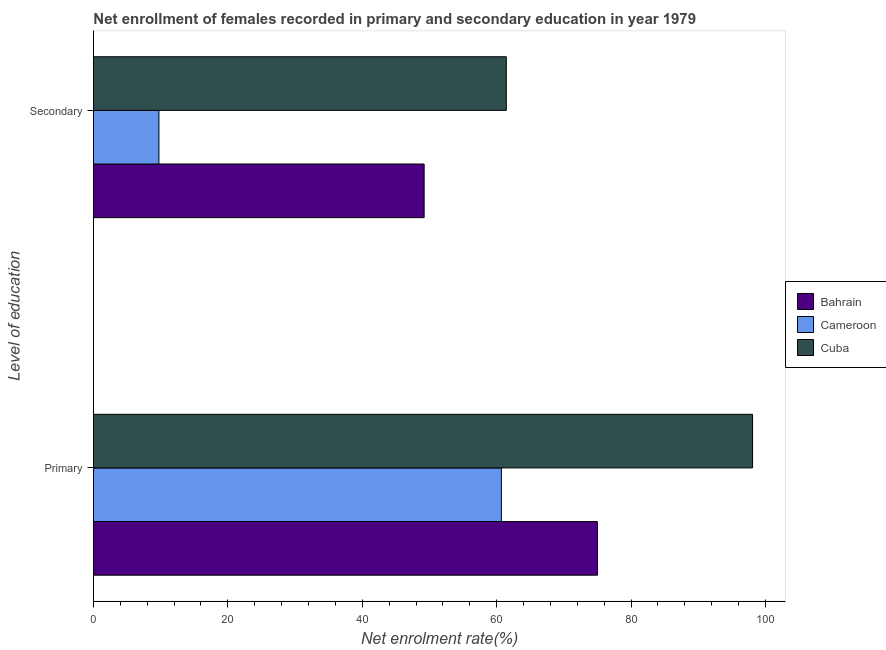How many different coloured bars are there?
Give a very brief answer. 3. How many groups of bars are there?
Offer a very short reply. 2. Are the number of bars on each tick of the Y-axis equal?
Offer a very short reply. Yes. What is the label of the 1st group of bars from the top?
Offer a very short reply. Secondary. What is the enrollment rate in secondary education in Cuba?
Offer a terse response. 61.44. Across all countries, what is the maximum enrollment rate in secondary education?
Your answer should be compact. 61.44. Across all countries, what is the minimum enrollment rate in secondary education?
Make the answer very short. 9.74. In which country was the enrollment rate in primary education maximum?
Your answer should be compact. Cuba. In which country was the enrollment rate in primary education minimum?
Provide a succinct answer. Cameroon. What is the total enrollment rate in primary education in the graph?
Provide a short and direct response. 233.79. What is the difference between the enrollment rate in primary education in Cuba and that in Bahrain?
Give a very brief answer. 23.09. What is the difference between the enrollment rate in primary education in Bahrain and the enrollment rate in secondary education in Cuba?
Offer a very short reply. 13.56. What is the average enrollment rate in primary education per country?
Offer a very short reply. 77.93. What is the difference between the enrollment rate in primary education and enrollment rate in secondary education in Cameroon?
Your answer should be very brief. 50.97. What is the ratio of the enrollment rate in primary education in Bahrain to that in Cuba?
Your answer should be compact. 0.76. Is the enrollment rate in primary education in Bahrain less than that in Cuba?
Keep it short and to the point. Yes. What does the 3rd bar from the top in Secondary represents?
Keep it short and to the point. Bahrain. What does the 1st bar from the bottom in Secondary represents?
Provide a succinct answer. Bahrain. How many countries are there in the graph?
Your response must be concise. 3. What is the difference between two consecutive major ticks on the X-axis?
Give a very brief answer. 20. Are the values on the major ticks of X-axis written in scientific E-notation?
Give a very brief answer. No. Does the graph contain any zero values?
Give a very brief answer. No. How are the legend labels stacked?
Your answer should be very brief. Vertical. What is the title of the graph?
Offer a terse response. Net enrollment of females recorded in primary and secondary education in year 1979. What is the label or title of the X-axis?
Give a very brief answer. Net enrolment rate(%). What is the label or title of the Y-axis?
Keep it short and to the point. Level of education. What is the Net enrolment rate(%) of Bahrain in Primary?
Provide a succinct answer. 75. What is the Net enrolment rate(%) of Cameroon in Primary?
Provide a short and direct response. 60.71. What is the Net enrolment rate(%) in Cuba in Primary?
Ensure brevity in your answer.  98.08. What is the Net enrolment rate(%) of Bahrain in Secondary?
Offer a very short reply. 49.21. What is the Net enrolment rate(%) of Cameroon in Secondary?
Provide a short and direct response. 9.74. What is the Net enrolment rate(%) of Cuba in Secondary?
Provide a succinct answer. 61.44. Across all Level of education, what is the maximum Net enrolment rate(%) in Bahrain?
Provide a short and direct response. 75. Across all Level of education, what is the maximum Net enrolment rate(%) in Cameroon?
Provide a succinct answer. 60.71. Across all Level of education, what is the maximum Net enrolment rate(%) in Cuba?
Offer a very short reply. 98.08. Across all Level of education, what is the minimum Net enrolment rate(%) in Bahrain?
Your answer should be very brief. 49.21. Across all Level of education, what is the minimum Net enrolment rate(%) in Cameroon?
Ensure brevity in your answer.  9.74. Across all Level of education, what is the minimum Net enrolment rate(%) in Cuba?
Give a very brief answer. 61.44. What is the total Net enrolment rate(%) of Bahrain in the graph?
Ensure brevity in your answer.  124.21. What is the total Net enrolment rate(%) of Cameroon in the graph?
Offer a very short reply. 70.44. What is the total Net enrolment rate(%) in Cuba in the graph?
Offer a terse response. 159.52. What is the difference between the Net enrolment rate(%) in Bahrain in Primary and that in Secondary?
Provide a succinct answer. 25.79. What is the difference between the Net enrolment rate(%) in Cameroon in Primary and that in Secondary?
Keep it short and to the point. 50.97. What is the difference between the Net enrolment rate(%) in Cuba in Primary and that in Secondary?
Make the answer very short. 36.64. What is the difference between the Net enrolment rate(%) in Bahrain in Primary and the Net enrolment rate(%) in Cameroon in Secondary?
Your answer should be very brief. 65.26. What is the difference between the Net enrolment rate(%) in Bahrain in Primary and the Net enrolment rate(%) in Cuba in Secondary?
Your response must be concise. 13.56. What is the difference between the Net enrolment rate(%) in Cameroon in Primary and the Net enrolment rate(%) in Cuba in Secondary?
Ensure brevity in your answer.  -0.73. What is the average Net enrolment rate(%) of Bahrain per Level of education?
Keep it short and to the point. 62.1. What is the average Net enrolment rate(%) in Cameroon per Level of education?
Make the answer very short. 35.22. What is the average Net enrolment rate(%) of Cuba per Level of education?
Your answer should be very brief. 79.76. What is the difference between the Net enrolment rate(%) in Bahrain and Net enrolment rate(%) in Cameroon in Primary?
Your answer should be compact. 14.29. What is the difference between the Net enrolment rate(%) of Bahrain and Net enrolment rate(%) of Cuba in Primary?
Offer a very short reply. -23.09. What is the difference between the Net enrolment rate(%) of Cameroon and Net enrolment rate(%) of Cuba in Primary?
Offer a very short reply. -37.38. What is the difference between the Net enrolment rate(%) in Bahrain and Net enrolment rate(%) in Cameroon in Secondary?
Keep it short and to the point. 39.47. What is the difference between the Net enrolment rate(%) of Bahrain and Net enrolment rate(%) of Cuba in Secondary?
Make the answer very short. -12.23. What is the difference between the Net enrolment rate(%) in Cameroon and Net enrolment rate(%) in Cuba in Secondary?
Your answer should be compact. -51.7. What is the ratio of the Net enrolment rate(%) in Bahrain in Primary to that in Secondary?
Your answer should be compact. 1.52. What is the ratio of the Net enrolment rate(%) of Cameroon in Primary to that in Secondary?
Provide a short and direct response. 6.23. What is the ratio of the Net enrolment rate(%) in Cuba in Primary to that in Secondary?
Provide a succinct answer. 1.6. What is the difference between the highest and the second highest Net enrolment rate(%) in Bahrain?
Your response must be concise. 25.79. What is the difference between the highest and the second highest Net enrolment rate(%) in Cameroon?
Your response must be concise. 50.97. What is the difference between the highest and the second highest Net enrolment rate(%) in Cuba?
Ensure brevity in your answer.  36.64. What is the difference between the highest and the lowest Net enrolment rate(%) in Bahrain?
Provide a succinct answer. 25.79. What is the difference between the highest and the lowest Net enrolment rate(%) in Cameroon?
Ensure brevity in your answer.  50.97. What is the difference between the highest and the lowest Net enrolment rate(%) in Cuba?
Your answer should be very brief. 36.64. 